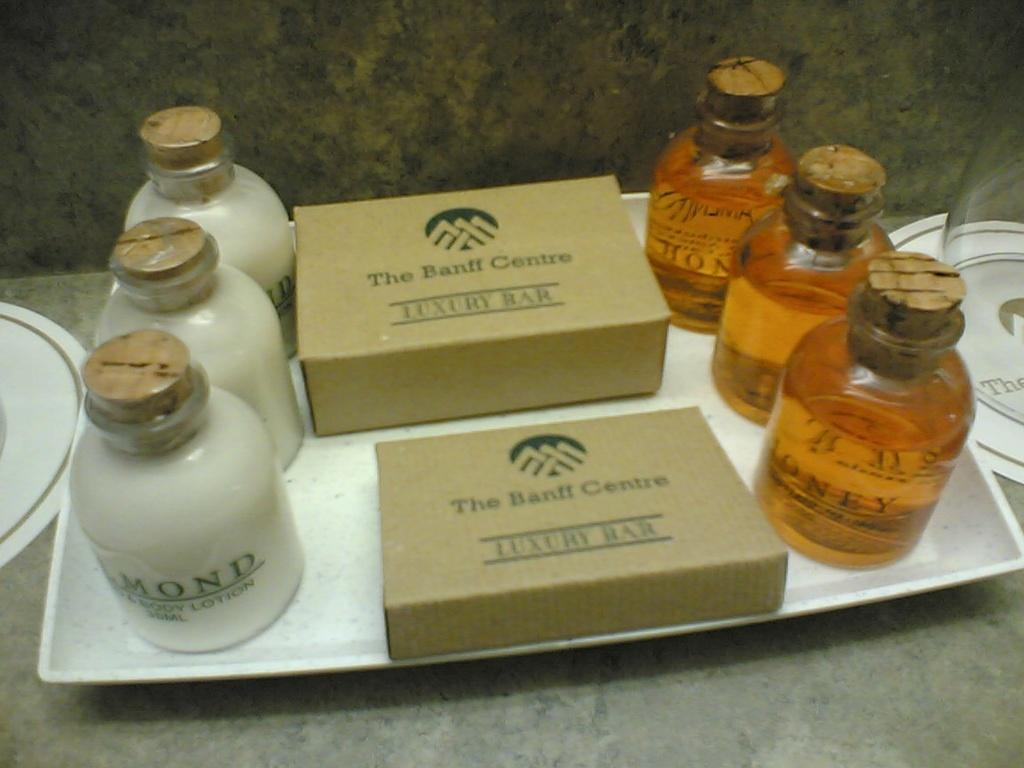What object is present in the image that can hold multiple items? There is a tray in the image that can hold multiple items. What items are on the tray? The tray contains bottles and two boxes. What colors are the bottles on the tray? The bottles are orange and white in color. What type of weather can be seen in the image? There is no weather visible in the image, as it is focused on a tray with bottles and boxes. Is there a farmer present in the image? There is no farmer present in the image. 